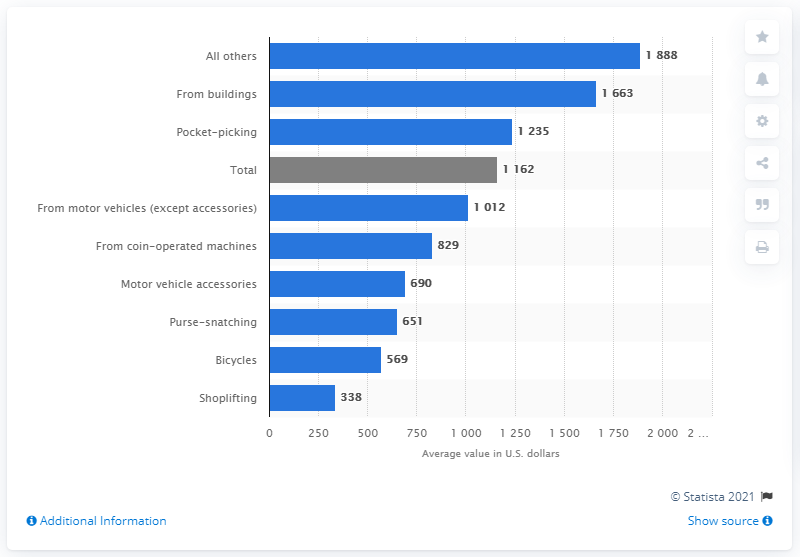Identify some key points in this picture. In 2019, the value of stolen bicycles was estimated to be approximately 569 million dollars. 